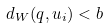Convert formula to latex. <formula><loc_0><loc_0><loc_500><loc_500>d _ { W } ( q , u _ { i } ) < b</formula> 